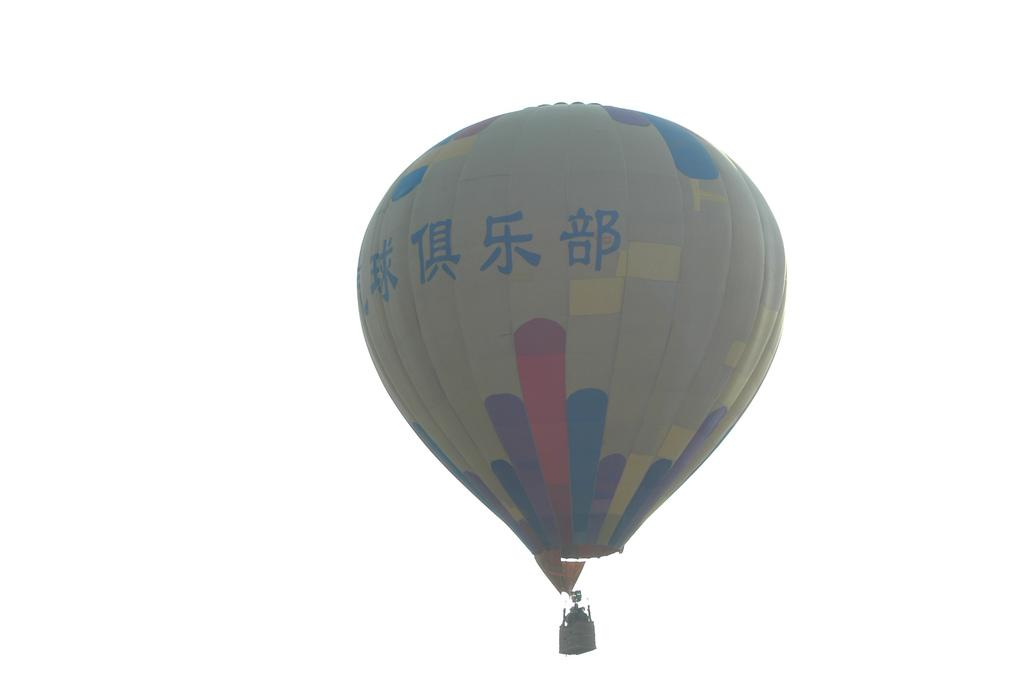What is suspended in the air in the image? There is a parachute in the air. What can be seen in the background of the image? The sky is visible in the background of the image. What type of rod is being used to stir the cup in the image? There is no rod or cup present in the image; it only features a parachute in the air and the sky in the background. 